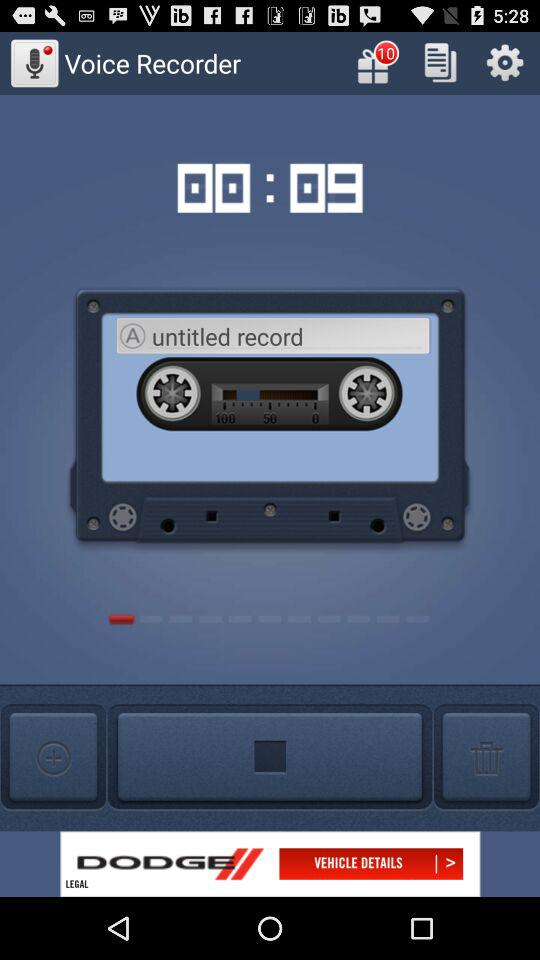What is the number of gift notifications shown on the screen? The number of gift notifications shown on the screen is 10. 